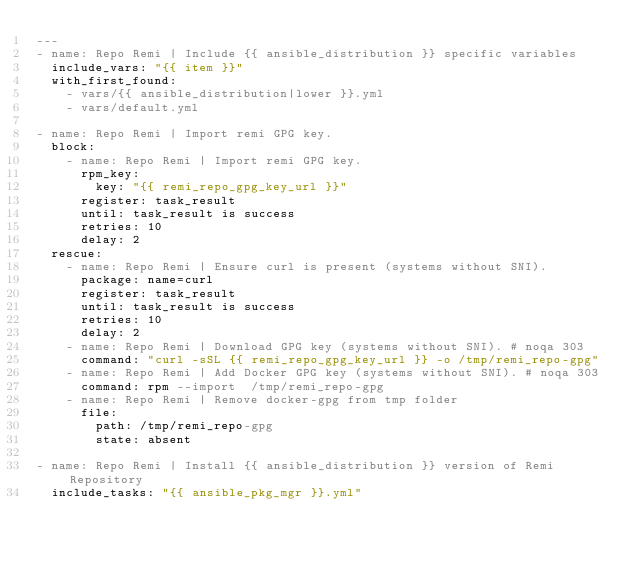<code> <loc_0><loc_0><loc_500><loc_500><_YAML_>---
- name: Repo Remi | Include {{ ansible_distribution }} specific variables
  include_vars: "{{ item }}"
  with_first_found:
    - vars/{{ ansible_distribution|lower }}.yml
    - vars/default.yml

- name: Repo Remi | Import remi GPG key.
  block:
    - name: Repo Remi | Import remi GPG key.
      rpm_key:
        key: "{{ remi_repo_gpg_key_url }}"
      register: task_result
      until: task_result is success
      retries: 10
      delay: 2
  rescue:
    - name: Repo Remi | Ensure curl is present (systems without SNI).
      package: name=curl
      register: task_result
      until: task_result is success
      retries: 10
      delay: 2
    - name: Repo Remi | Download GPG key (systems without SNI). # noqa 303
      command: "curl -sSL {{ remi_repo_gpg_key_url }} -o /tmp/remi_repo-gpg"
    - name: Repo Remi | Add Docker GPG key (systems without SNI). # noqa 303
      command: rpm --import  /tmp/remi_repo-gpg
    - name: Repo Remi | Remove docker-gpg from tmp folder
      file:
        path: /tmp/remi_repo-gpg
        state: absent

- name: Repo Remi | Install {{ ansible_distribution }} version of Remi Repository
  include_tasks: "{{ ansible_pkg_mgr }}.yml"
</code> 